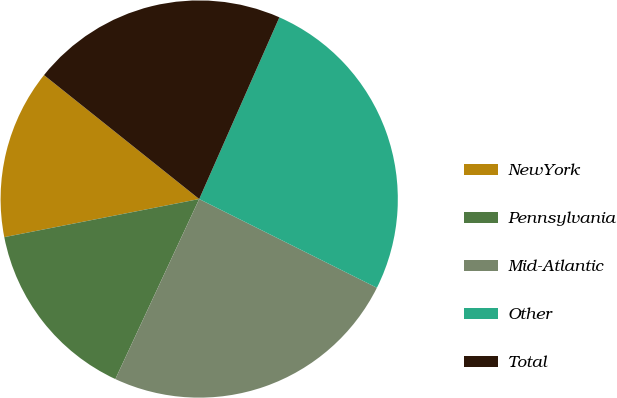Convert chart. <chart><loc_0><loc_0><loc_500><loc_500><pie_chart><fcel>NewYork<fcel>Pennsylvania<fcel>Mid-Atlantic<fcel>Other<fcel>Total<nl><fcel>13.8%<fcel>14.99%<fcel>24.57%<fcel>25.76%<fcel>20.89%<nl></chart> 